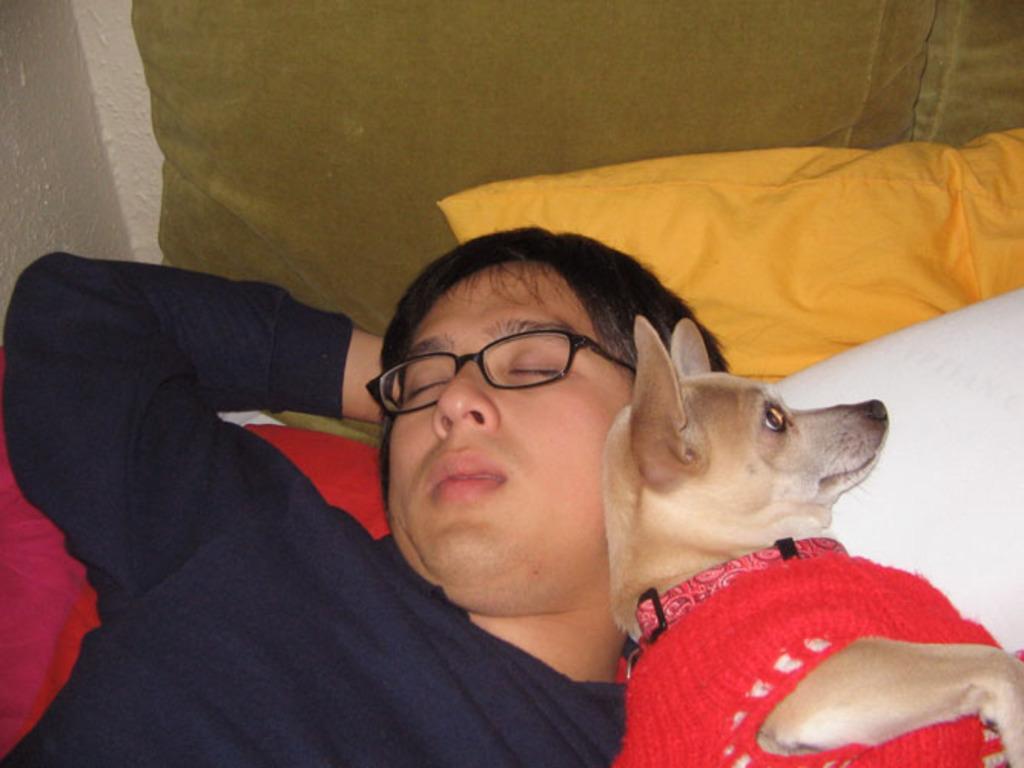Please provide a concise description of this image. In this picture, we see a man and a dog on the bed and we see a pillow 